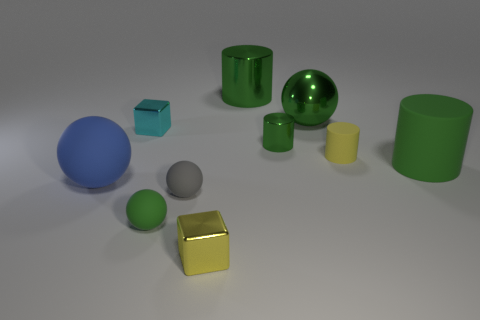How many green cylinders must be subtracted to get 1 green cylinders? 2 Subtract all cubes. How many objects are left? 8 Subtract 1 cubes. How many cubes are left? 1 Subtract all gray spheres. How many spheres are left? 3 Subtract all green cylinders. How many cylinders are left? 1 Subtract 0 green cubes. How many objects are left? 10 Subtract all cyan spheres. Subtract all gray blocks. How many spheres are left? 4 Subtract all red cylinders. How many brown cubes are left? 0 Subtract all tiny yellow cubes. Subtract all large shiny cylinders. How many objects are left? 8 Add 7 small green metallic objects. How many small green metallic objects are left? 8 